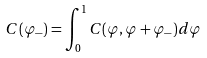<formula> <loc_0><loc_0><loc_500><loc_500>C ( \varphi _ { - } ) = \int _ { 0 } ^ { 1 } C ( \varphi , \varphi + \varphi _ { - } ) d \varphi</formula> 